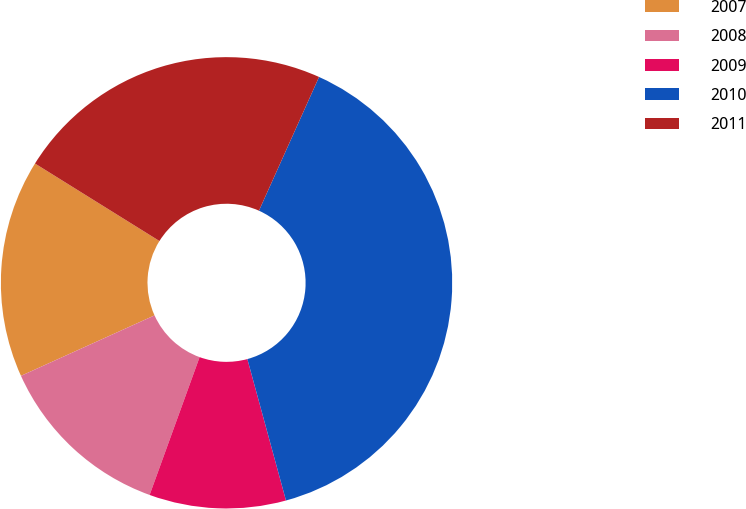Convert chart to OTSL. <chart><loc_0><loc_0><loc_500><loc_500><pie_chart><fcel>2007<fcel>2008<fcel>2009<fcel>2010<fcel>2011<nl><fcel>15.63%<fcel>12.7%<fcel>9.78%<fcel>39.04%<fcel>22.86%<nl></chart> 